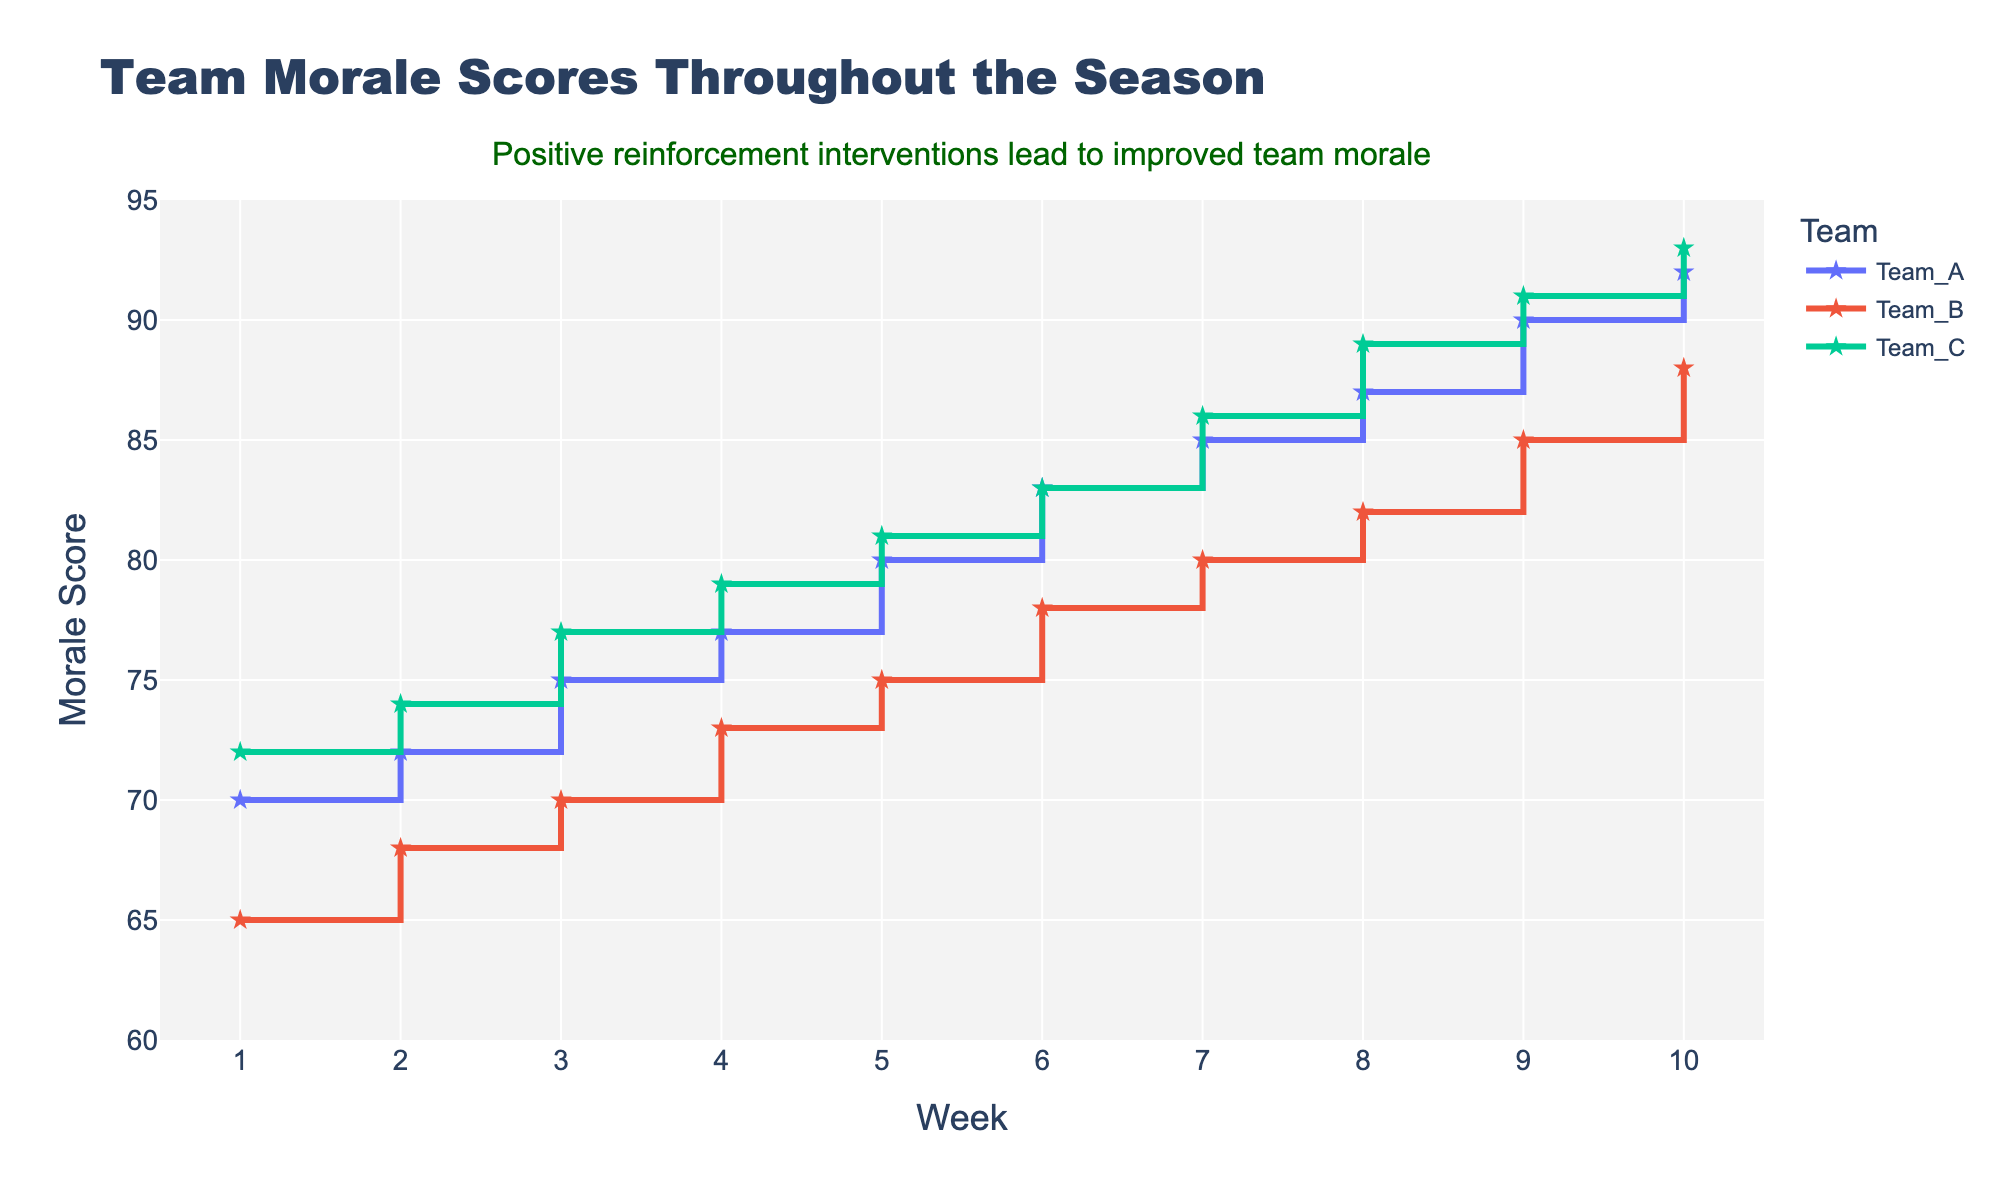What is the title of the figure? The title of the figure is located at the top and reads, "Team Morale Scores Throughout the Season."
Answer: Team Morale Scores Throughout the Season How many teams are represented in the figure? The figure includes lines for three different teams, visible in the legend on the right side of the plot.
Answer: Three Which team has the highest morale score at the end of the season? At week 10, the figure shows the highest morale score for Team C, which reaches 93.
Answer: Team C What is the range of weeks displayed on the x-axis? The x-axis is labeled "Week" and ranges from 1 to 10, clearly indicated by the tick marks.
Answer: 1 to 10 What is the overall trend seen in the morale scores for all teams throughout the season? All lines for the teams show an upward trajectory as the weeks progress, indicating that morale scores generally improve over the season.
Answer: Morale scores improve Which team starts with the highest morale score in Week 1? Week 1 shows that Team C has the highest starting morale score at 72, higher than both Team A and Team B.
Answer: Team C How does the morale score of Team A change from Week 3 to Week 6? The chart shows that Team A's morale score increases from 75 in Week 3 to 83 in Week 6.
Answer: Increases Between Weeks 4 and 7, which team shows the highest increase in morale score? By comparing the vertical steps in the lines for each team between Weeks 4 and 7: Team A increases from 77 to 85 (+8), Team B increases from 73 to 80 (+7), and Team C increases from 79 to 86 (+7). Team A shows the highest increase.
Answer: Team A What is the average morale score of Team B at the end of Weeks 5 and 10? Adding the morale scores for Team B at Week 5 (75) and Week 10 (88), then dividing by 2: (75 + 88) / 2 = 81.5.
Answer: 81.5 What feature is added to emphasize the positive reinforcement interventions? The annotation at the top of the plot states, "Positive reinforcement interventions lead to improved team morale," emphasizing the intervention's impact.
Answer: Annotation 